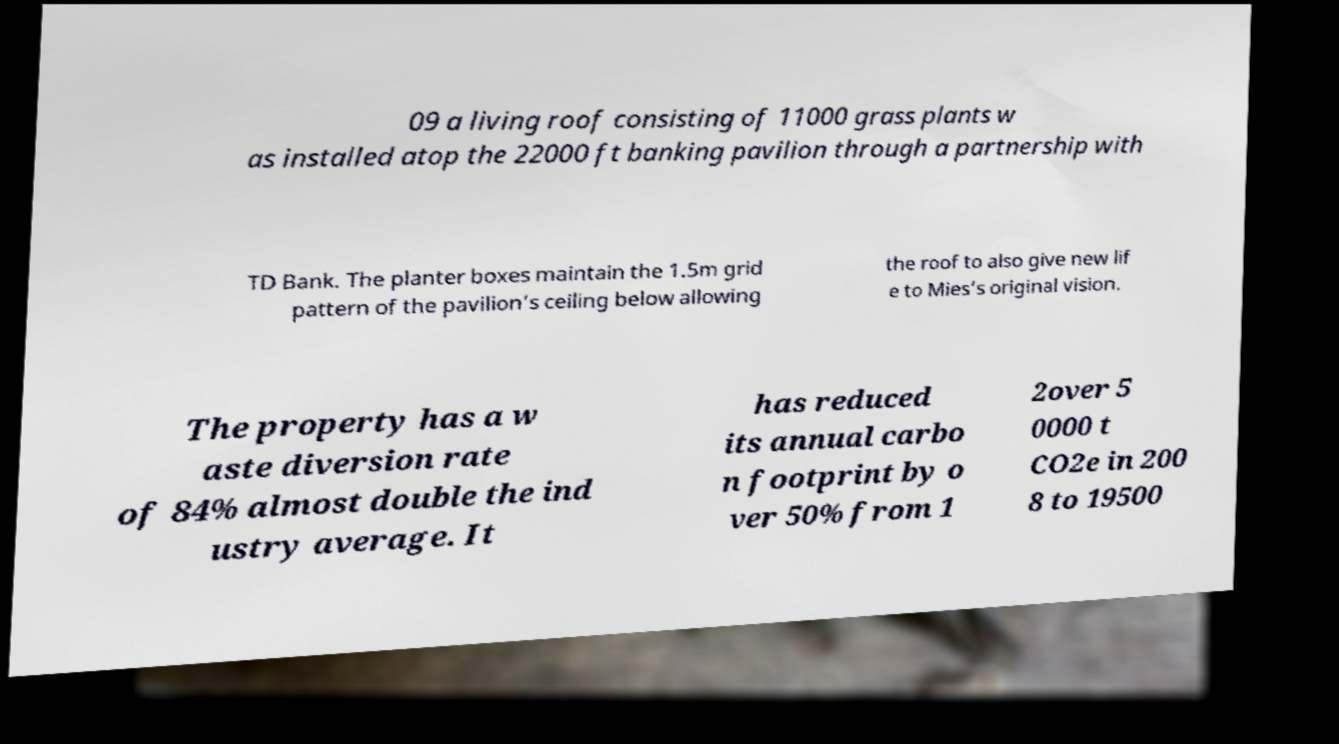For documentation purposes, I need the text within this image transcribed. Could you provide that? 09 a living roof consisting of 11000 grass plants w as installed atop the 22000 ft banking pavilion through a partnership with TD Bank. The planter boxes maintain the 1.5m grid pattern of the pavilion’s ceiling below allowing the roof to also give new lif e to Mies’s original vision. The property has a w aste diversion rate of 84% almost double the ind ustry average. It has reduced its annual carbo n footprint by o ver 50% from 1 2over 5 0000 t CO2e in 200 8 to 19500 